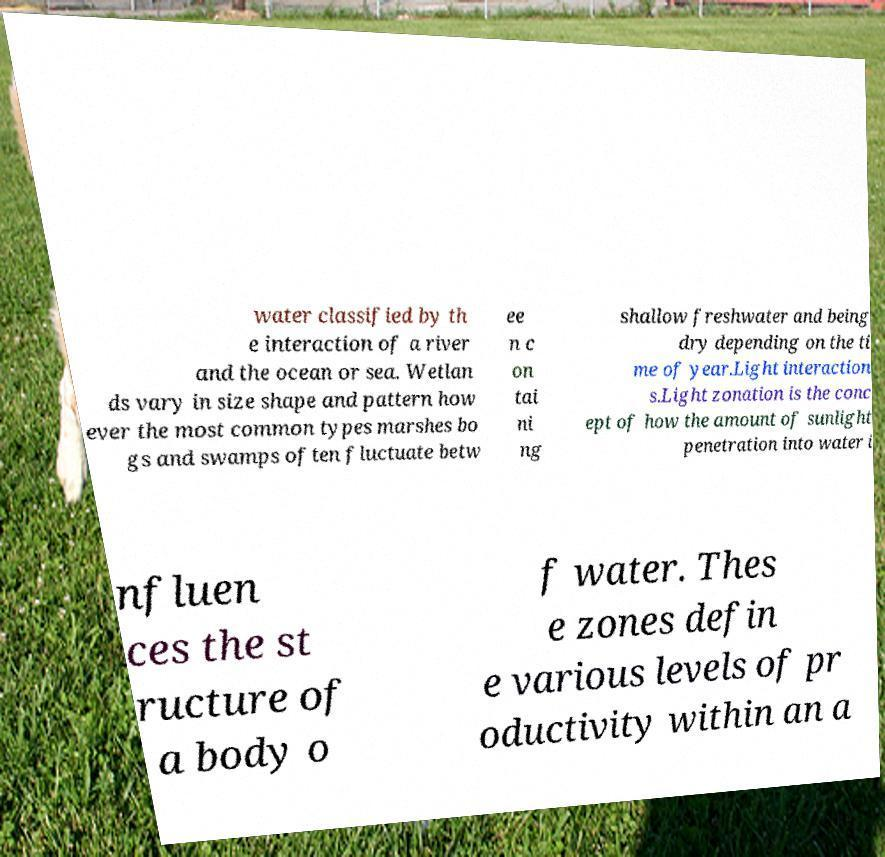What messages or text are displayed in this image? I need them in a readable, typed format. water classified by th e interaction of a river and the ocean or sea. Wetlan ds vary in size shape and pattern how ever the most common types marshes bo gs and swamps often fluctuate betw ee n c on tai ni ng shallow freshwater and being dry depending on the ti me of year.Light interaction s.Light zonation is the conc ept of how the amount of sunlight penetration into water i nfluen ces the st ructure of a body o f water. Thes e zones defin e various levels of pr oductivity within an a 